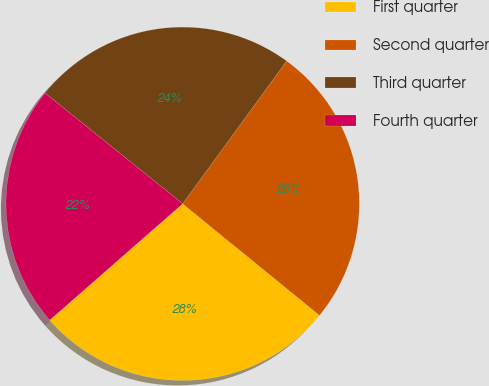<chart> <loc_0><loc_0><loc_500><loc_500><pie_chart><fcel>First quarter<fcel>Second quarter<fcel>Third quarter<fcel>Fourth quarter<nl><fcel>27.67%<fcel>25.87%<fcel>24.24%<fcel>22.23%<nl></chart> 